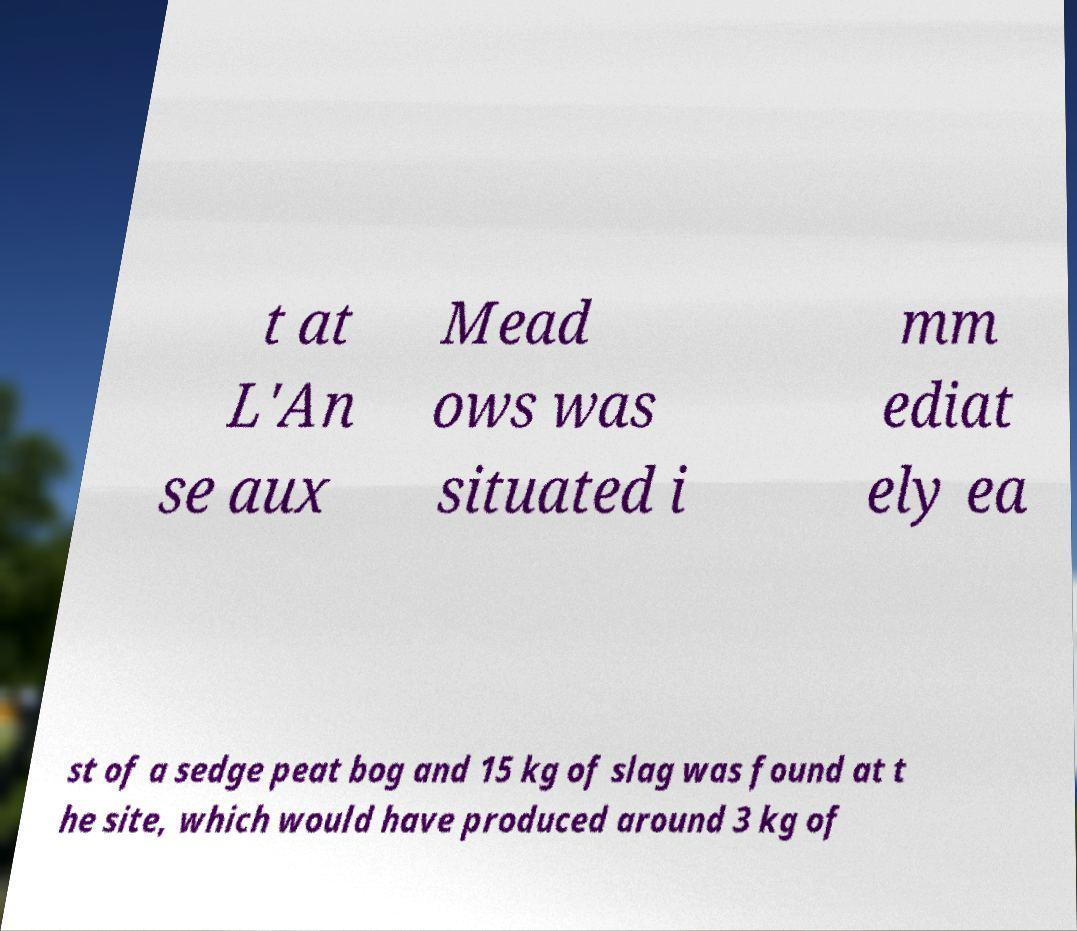Can you read and provide the text displayed in the image?This photo seems to have some interesting text. Can you extract and type it out for me? t at L'An se aux Mead ows was situated i mm ediat ely ea st of a sedge peat bog and 15 kg of slag was found at t he site, which would have produced around 3 kg of 